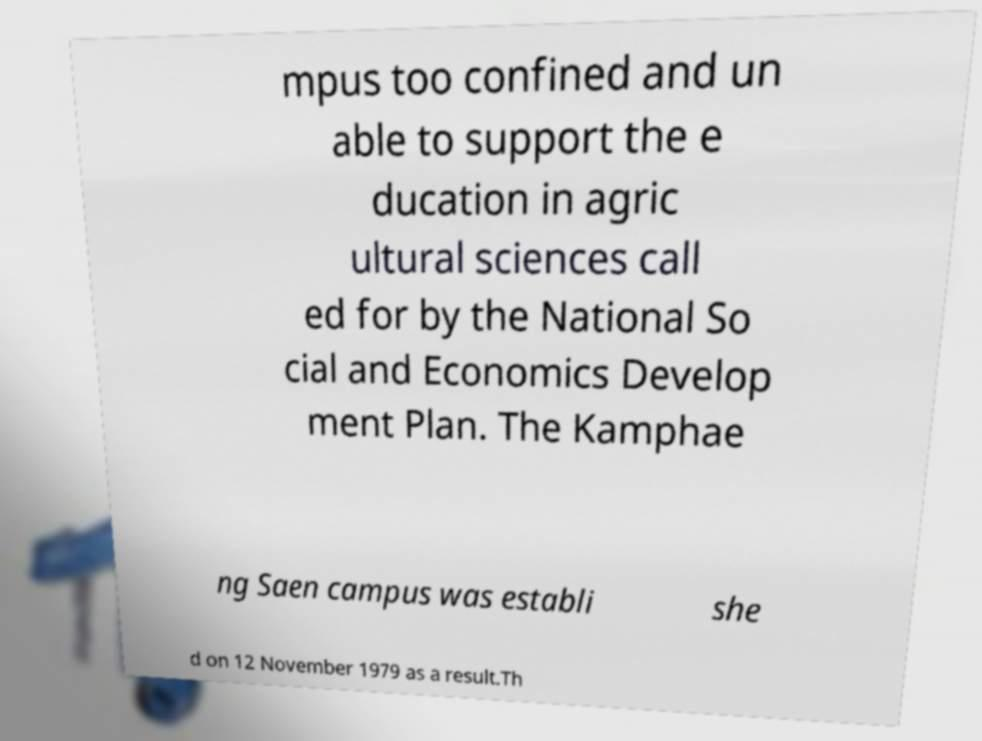I need the written content from this picture converted into text. Can you do that? mpus too confined and un able to support the e ducation in agric ultural sciences call ed for by the National So cial and Economics Develop ment Plan. The Kamphae ng Saen campus was establi she d on 12 November 1979 as a result.Th 